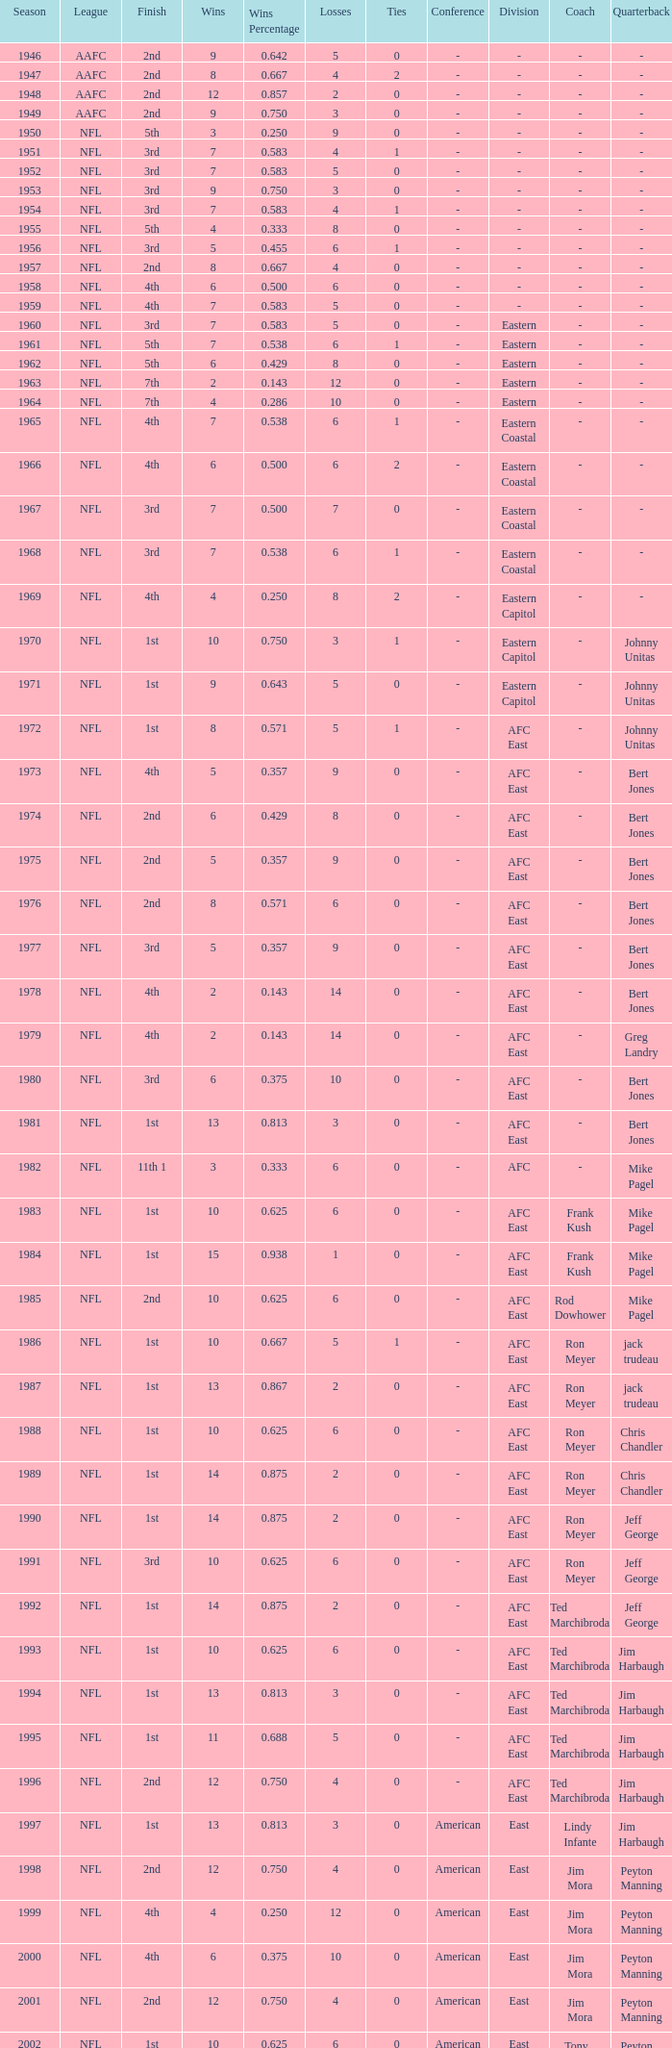What league had a finish of 2nd and 3 losses? AAFC. 